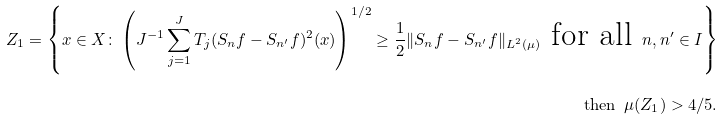<formula> <loc_0><loc_0><loc_500><loc_500>Z _ { 1 } = \left \{ x \in X \colon \left ( J ^ { - 1 } \sum _ { j = 1 } ^ { J } T _ { j } ( S _ { n } f - S _ { n ^ { \prime } } f ) ^ { 2 } ( x ) \right ) ^ { 1 / 2 } \geq \frac { 1 } { 2 } \| S _ { n } f - S _ { n ^ { \prime } } f \| _ { L ^ { 2 } ( \mu ) } \text { for all } n , n ^ { \prime } \in I \right \} \\ \text {then } \, \mu ( Z _ { 1 } ) > 4 / 5 .</formula> 